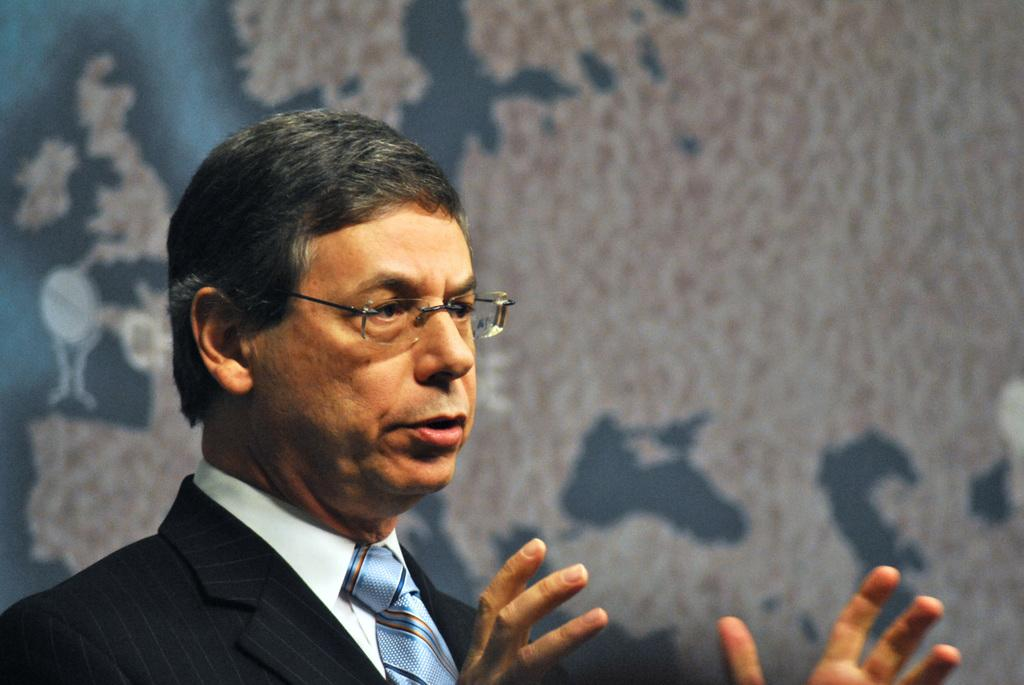What is the main subject in the foreground of the image? There is a person in the foreground of the image. What is the person wearing? The person is wearing a suit. What can be seen in the background of the image? There is a wall with a design in the background of the image. What type of mask is the person wearing in the image? There is no mask visible in the image; the person is wearing a suit. What type of drink is the person holding in the image? There is no drink visible in the image; the person is not holding anything. 